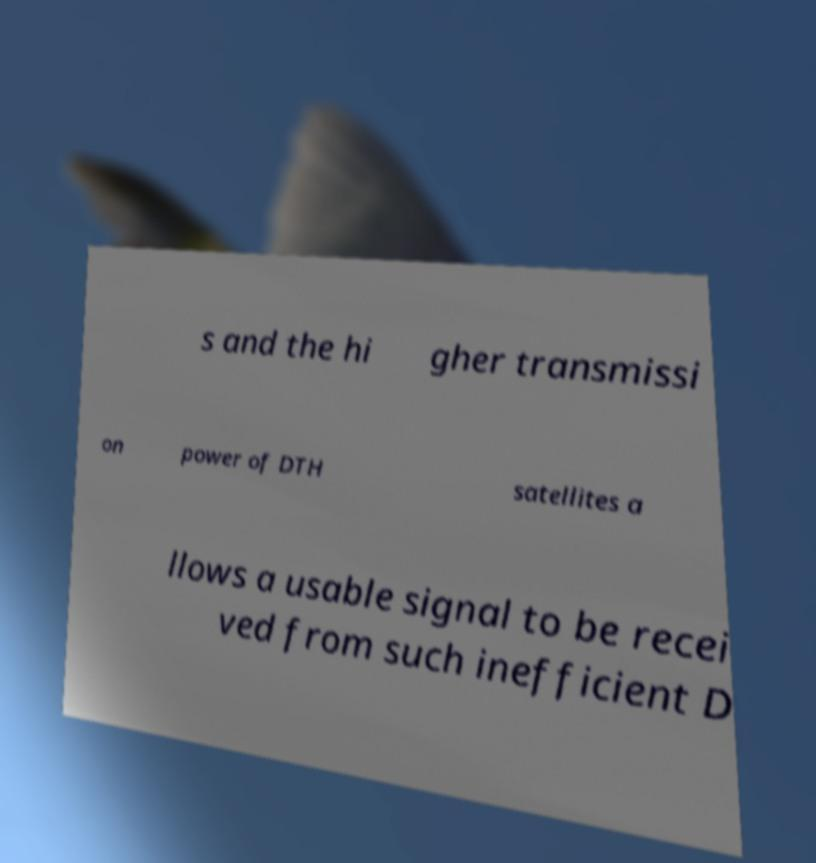Please identify and transcribe the text found in this image. s and the hi gher transmissi on power of DTH satellites a llows a usable signal to be recei ved from such inefficient D 